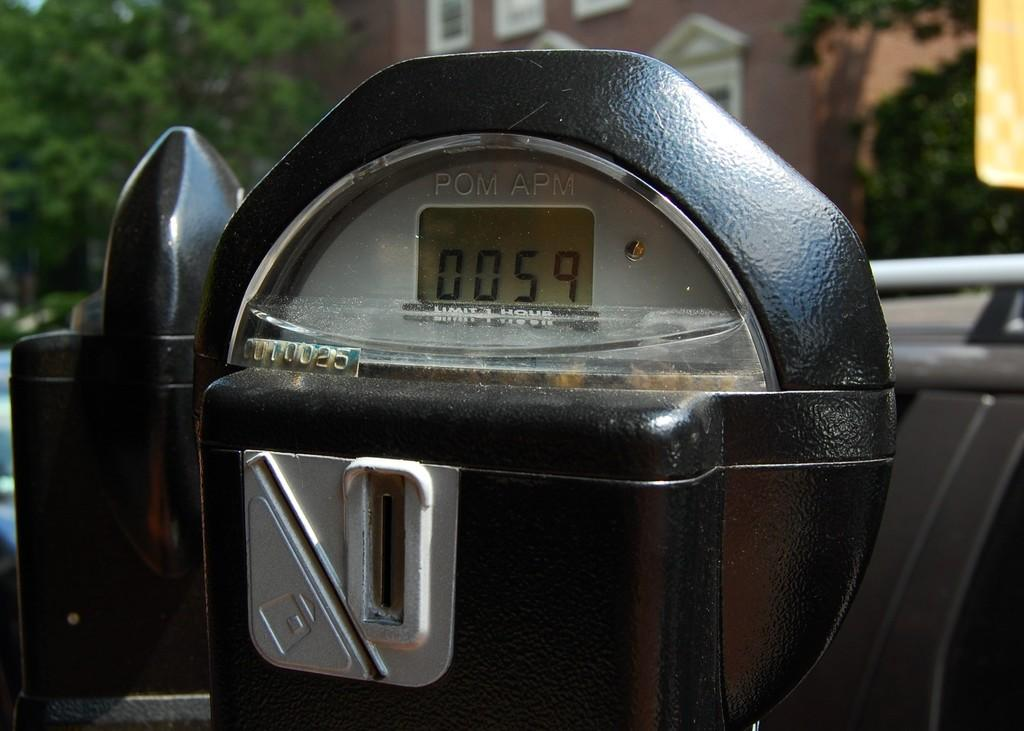<image>
Render a clear and concise summary of the photo. A parking meter with a display of 0059 and a serial number of 0U10025 